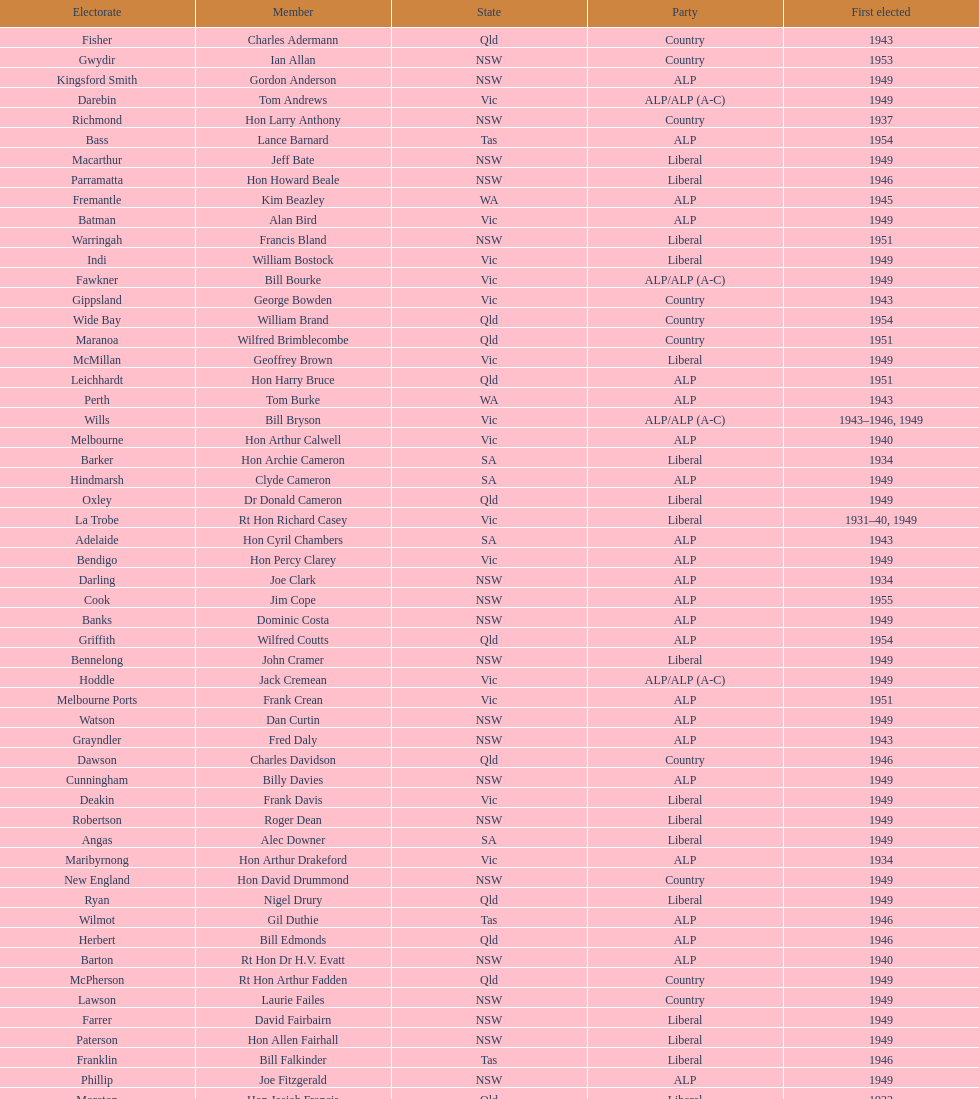When was joe clark first elected? 1934. 